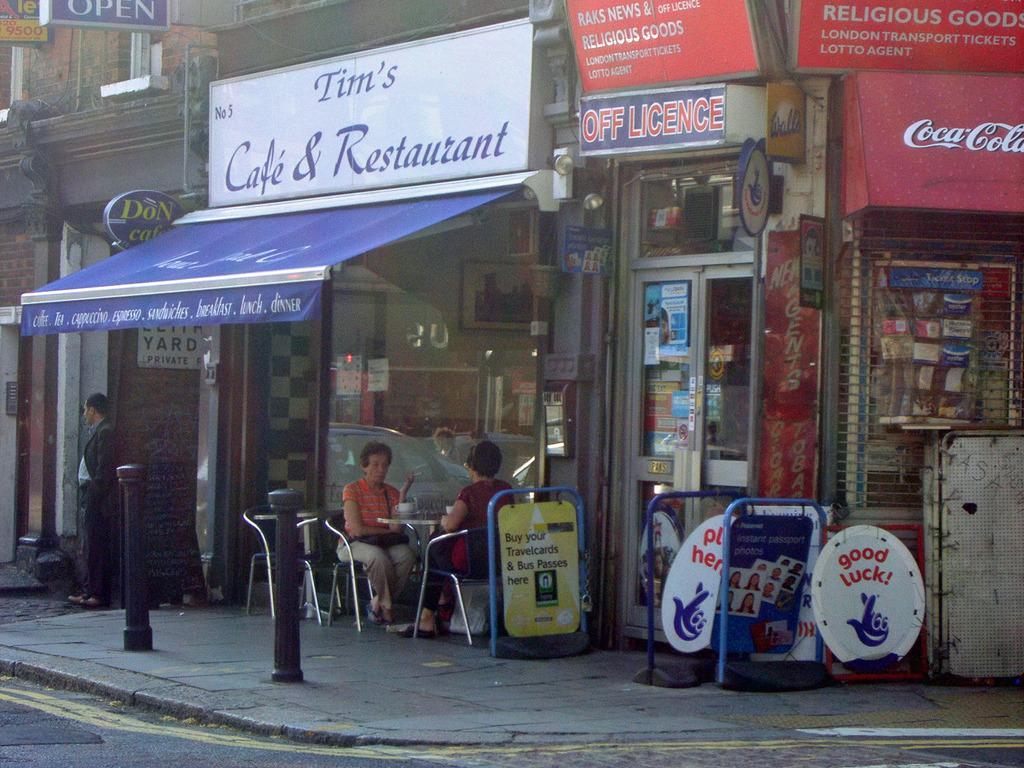Describe this image in one or two sentences. In this image, I can see two persons sitting on the chairs and a person standing. There are shops with name boards, glass doors, and posters. I can see two tables, empty chairs and poles on the pathway. 